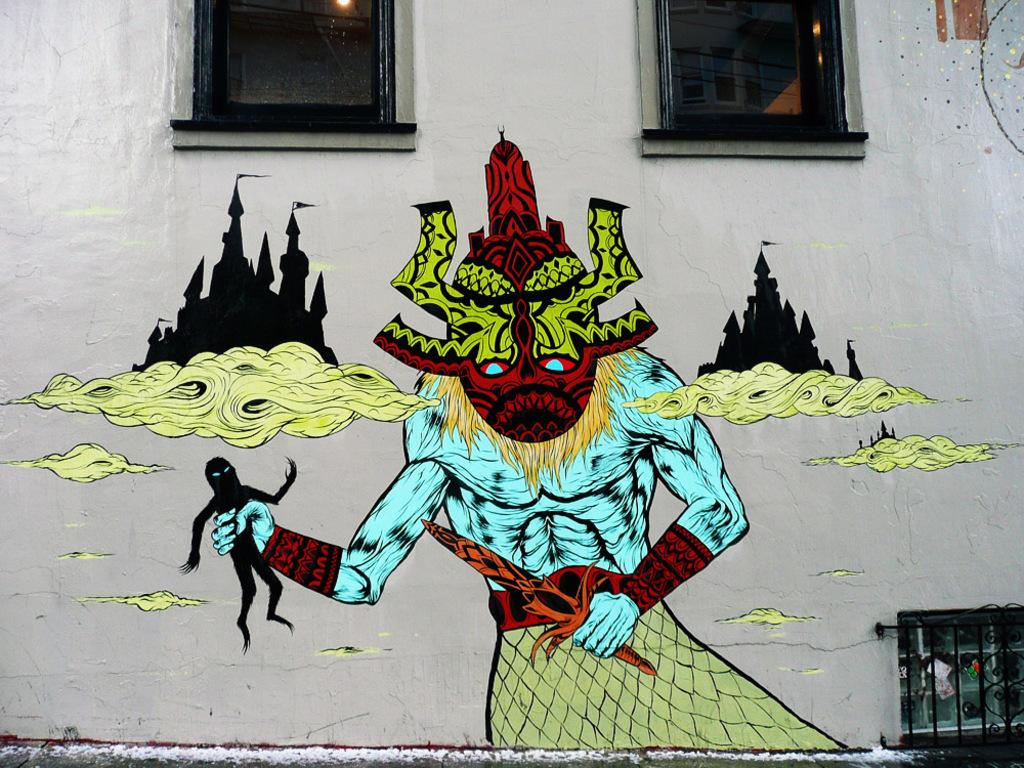What type of structure is present in the image? There is a glass window in the image. What can be seen on the wall in the image? There is a painting of a devil on the wall in the image. What month is the receipt dated in the image? There is no receipt present in the image. What verse can be found in the painting of the devil in the image? The painting of the devil does not contain any verses; it is a visual representation of a devil. 